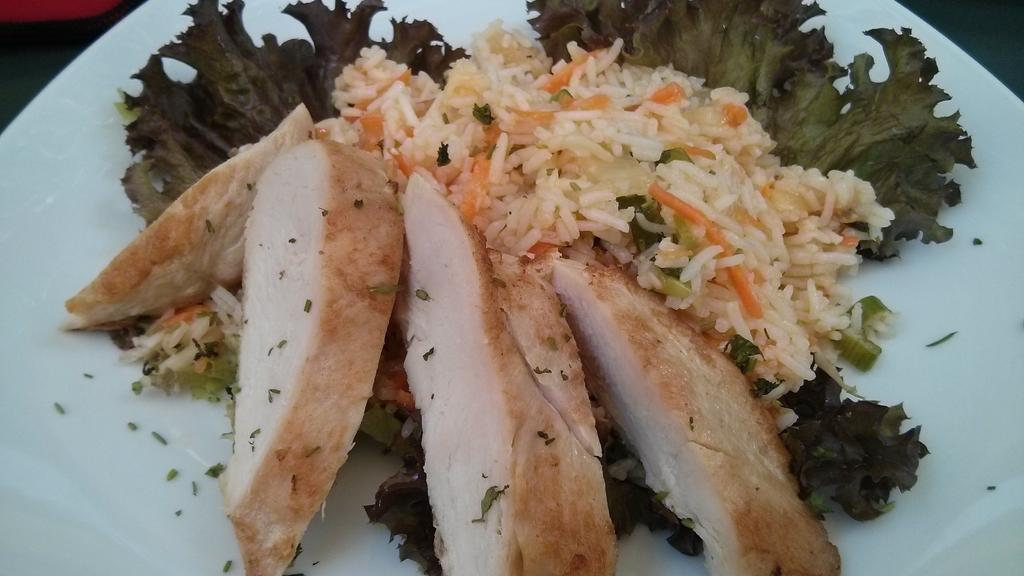What is present on the plate in the image? There are food items in a plate. Can you describe the unspecified object beside the plate? Unfortunately, the facts provided do not give any details about the object beside the plate. What type of rose can be seen in the image? There is no rose present in the image. Is the image taken in a bedroom? The facts provided do not give any information about the location or setting of the image. 